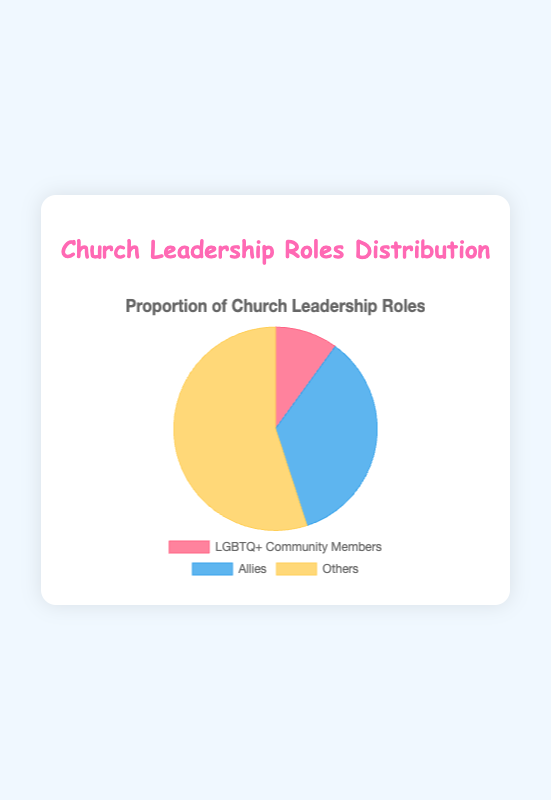What proportion of leadership roles are held by allies in the church? To find the proportion of leadership roles held by allies, you simply refer to the chart where the dataset for "Allies" is given as 35.
Answer: 35% Are there more allies or others holding leadership roles? Comparing the values from the chart, allies hold 35% of the roles while others hold 55%. Since 55% is greater than 35%, others hold more roles than allies.
Answer: Others What is the combined proportion of leadership roles held by allies and LGBTQ+ community members? To find the combined proportion, add the percentages of allies (35%) and LGBTQ+ community members (10%). Therefore, 35% + 10% = 45%.
Answer: 45% Which group has the least proportion of leadership roles? Refer to the chart for the smallest percentage: LGBTQ+ community members hold 10%, allies hold 35%, and others hold 55%. The smallest value is 10%, so the LGBTQ+ community holds the least proportion.
Answer: LGBTQ+ Community Members What is the difference in the proportion of leadership roles between allies and others? Subtract the proportion of allies (35%) from the proportion of others (55%). Therefore, 55% - 35% = 20%.
Answer: 20% If the church had 100 leadership roles, how many would be held by LGBTQ+ community members? If there are 100 leadership roles, and 10% are held by LGBTQ+ community members, then 10% of 100 is calculated as (10/100) * 100 = 10.
Answer: 10 Which group holds more than half of the leadership roles? From the chart, observe that others hold 55% of the roles; over half of 100.
Answer: Others What color represents the segment for allies in the pie chart? Visually inspect the pie chart; the segment for allies is shown in a light blue color.
Answer: Light Blue How many groups have a proportion below 50%? From the chart, both LGBTQ+ community members (10%) and allies (35%) hold proportions below 50%. Only the others (55%) exceed this threshold.
Answer: 2 By what factor is the proportion of leadership roles held by others greater than those held by LGBTQ+ community members? To find the factor, divide the proportion of others (55%) by the proportion of LGBTQ+ community members (10%): 55 / 10 = 5.5.
Answer: 5.5 